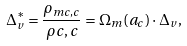<formula> <loc_0><loc_0><loc_500><loc_500>\Delta _ { v } ^ { * } = \frac { \rho _ { m c , c } } { \rho { c , c } } = \Omega _ { m } ( a _ { c } ) \cdot \Delta _ { v } ,</formula> 